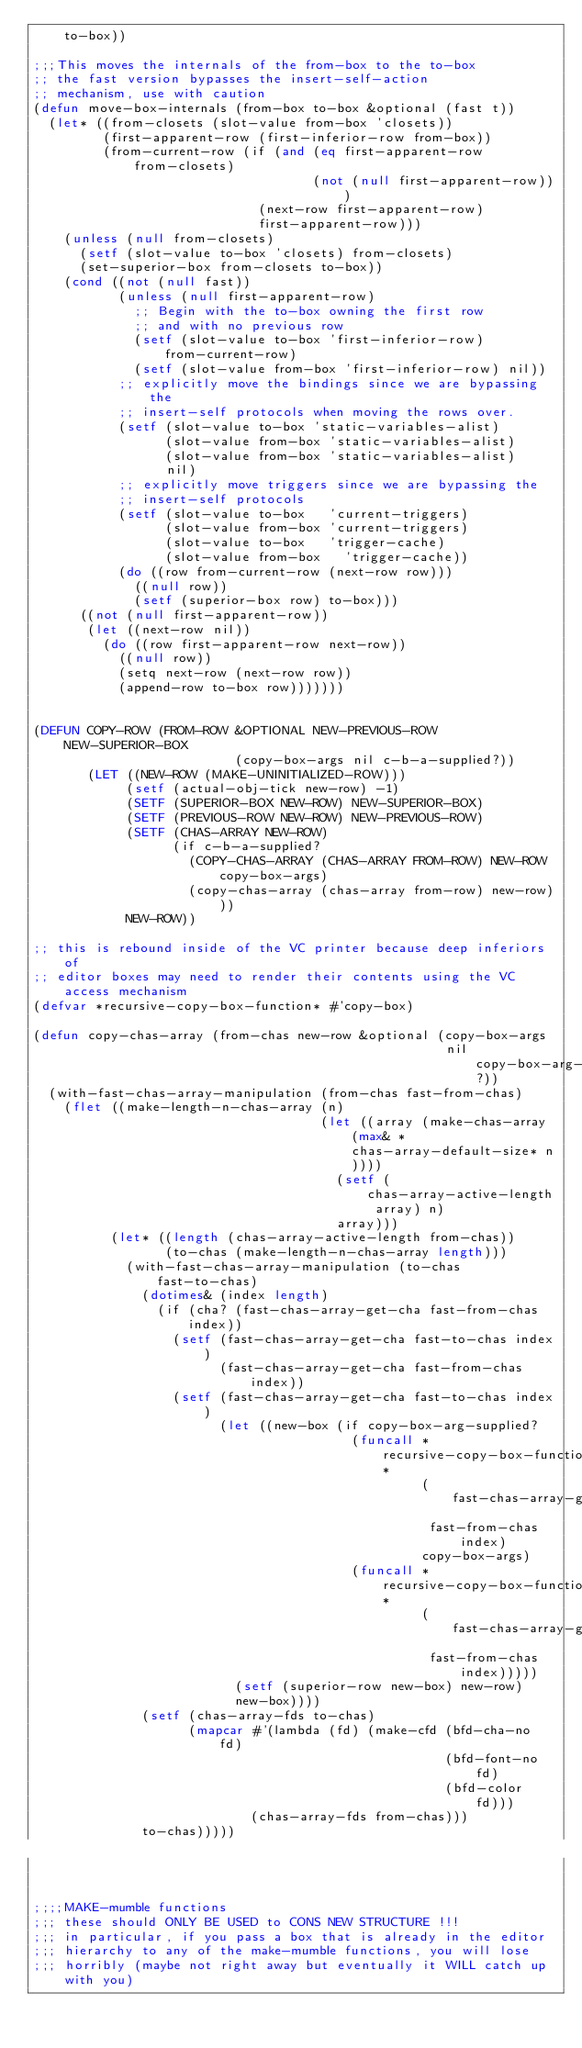Convert code to text. <code><loc_0><loc_0><loc_500><loc_500><_Lisp_>    to-box))

;;;This moves the internals of the from-box to the to-box
;; the fast version bypasses the insert-self-action
;; mechanism, use with caution
(defun move-box-internals (from-box to-box &optional (fast t))
  (let* ((from-closets (slot-value from-box 'closets))
         (first-apparent-row (first-inferior-row from-box))
         (from-current-row (if (and (eq first-apparent-row from-closets)
                                    (not (null first-apparent-row)))
                             (next-row first-apparent-row)
                             first-apparent-row)))
    (unless (null from-closets)
      (setf (slot-value to-box 'closets) from-closets)
      (set-superior-box from-closets to-box))
    (cond ((not (null fast))
           (unless (null first-apparent-row)
             ;; Begin with the to-box owning the first row
             ;; and with no previous row
             (setf (slot-value to-box 'first-inferior-row) from-current-row)
             (setf (slot-value from-box 'first-inferior-row) nil))
           ;; explicitly move the bindings since we are bypassing the
           ;; insert-self protocols when moving the rows over.
           (setf (slot-value to-box 'static-variables-alist)
                 (slot-value from-box 'static-variables-alist)
                 (slot-value from-box 'static-variables-alist)
                 nil)
           ;; explicitly move triggers since we are bypassing the
           ;; insert-self protocols
           (setf (slot-value to-box   'current-triggers)
                 (slot-value from-box 'current-triggers)
                 (slot-value to-box   'trigger-cache)
                 (slot-value from-box   'trigger-cache))
           (do ((row from-current-row (next-row row)))
             ((null row))
             (setf (superior-box row) to-box)))
      ((not (null first-apparent-row))
       (let ((next-row nil))
         (do ((row first-apparent-row next-row))
           ((null row))
           (setq next-row (next-row row))
           (append-row to-box row)))))))


(DEFUN COPY-ROW (FROM-ROW &OPTIONAL NEW-PREVIOUS-ROW NEW-SUPERIOR-BOX
                          (copy-box-args nil c-b-a-supplied?))
       (LET ((NEW-ROW (MAKE-UNINITIALIZED-ROW)))
            (setf (actual-obj-tick new-row) -1)
            (SETF (SUPERIOR-BOX NEW-ROW) NEW-SUPERIOR-BOX)
            (SETF (PREVIOUS-ROW NEW-ROW) NEW-PREVIOUS-ROW)
            (SETF (CHAS-ARRAY NEW-ROW)
                  (if c-b-a-supplied?
                    (COPY-CHAS-ARRAY (CHAS-ARRAY FROM-ROW) NEW-ROW copy-box-args)
                    (copy-chas-array (chas-array from-row) new-row)))
            NEW-ROW))

;; this is rebound inside of the VC printer because deep inferiors of
;; editor boxes may need to render their contents using the VC access mechanism
(defvar *recursive-copy-box-function* #'copy-box)

(defun copy-chas-array (from-chas new-row &optional (copy-box-args
                                                     nil copy-box-arg-supplied?))
  (with-fast-chas-array-manipulation (from-chas fast-from-chas)
    (flet ((make-length-n-chas-array (n)
                                     (let ((array (make-chas-array (max& *chas-array-default-size* n))))
                                       (setf (chas-array-active-length array) n)
                                       array)))
          (let* ((length (chas-array-active-length from-chas))
                 (to-chas (make-length-n-chas-array length)))
            (with-fast-chas-array-manipulation (to-chas fast-to-chas)
              (dotimes& (index length)
                (if (cha? (fast-chas-array-get-cha fast-from-chas index))
                  (setf (fast-chas-array-get-cha fast-to-chas index)
                        (fast-chas-array-get-cha fast-from-chas index))
                  (setf (fast-chas-array-get-cha fast-to-chas index)
                        (let ((new-box (if copy-box-arg-supplied?
                                         (funcall *recursive-copy-box-function*
                                                  (fast-chas-array-get-cha
                                                   fast-from-chas index)
                                                  copy-box-args)
                                         (funcall *recursive-copy-box-function*
                                                  (fast-chas-array-get-cha
                                                   fast-from-chas index)))))
                          (setf (superior-row new-box) new-row)
                          new-box))))
              (setf (chas-array-fds to-chas)
                    (mapcar #'(lambda (fd) (make-cfd (bfd-cha-no  fd)
                                                     (bfd-font-no fd)
                                                     (bfd-color   fd)))
                            (chas-array-fds from-chas)))
              to-chas)))))



;;;;MAKE-mumble functions
;;; these should ONLY BE USED to CONS NEW STRUCTURE !!!
;;; in particular, if you pass a box that is already in the editor
;;; hierarchy to any of the make-mumble functions, you will lose
;;; horribly (maybe not right away but eventually it WILL catch up with you)
</code> 